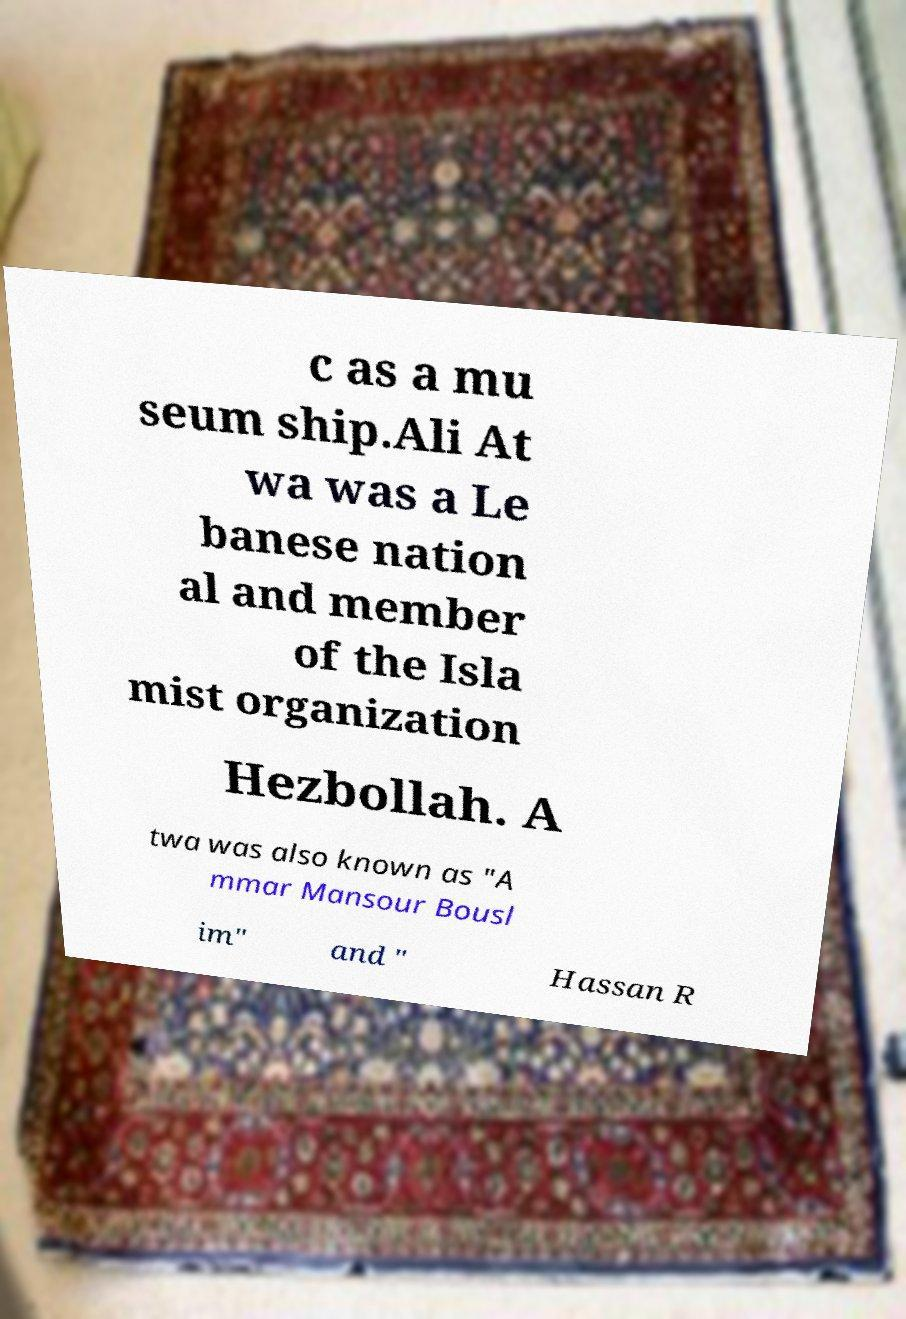Can you read and provide the text displayed in the image?This photo seems to have some interesting text. Can you extract and type it out for me? c as a mu seum ship.Ali At wa was a Le banese nation al and member of the Isla mist organization Hezbollah. A twa was also known as "A mmar Mansour Bousl im" and " Hassan R 